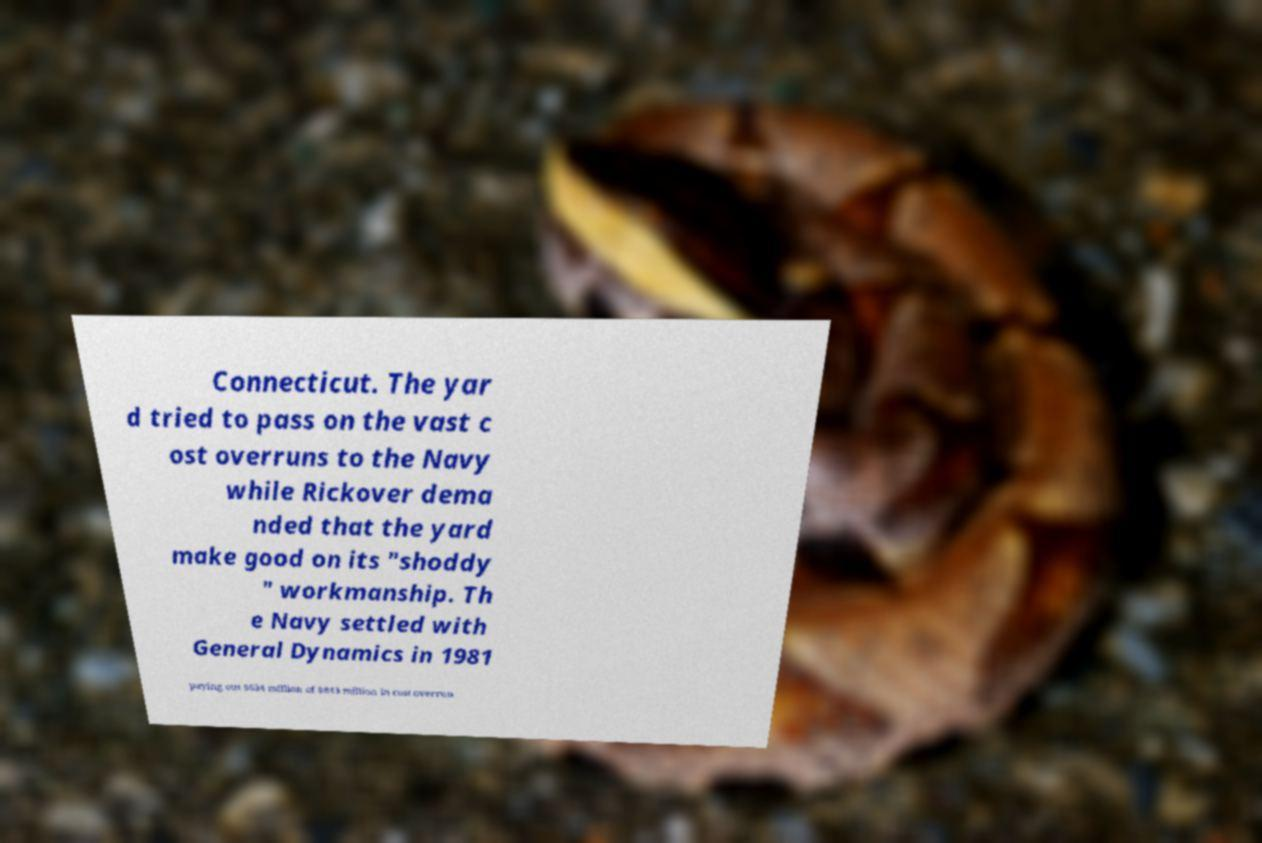I need the written content from this picture converted into text. Can you do that? Connecticut. The yar d tried to pass on the vast c ost overruns to the Navy while Rickover dema nded that the yard make good on its "shoddy " workmanship. Th e Navy settled with General Dynamics in 1981 paying out $634 million of $843 million in cost overrun 